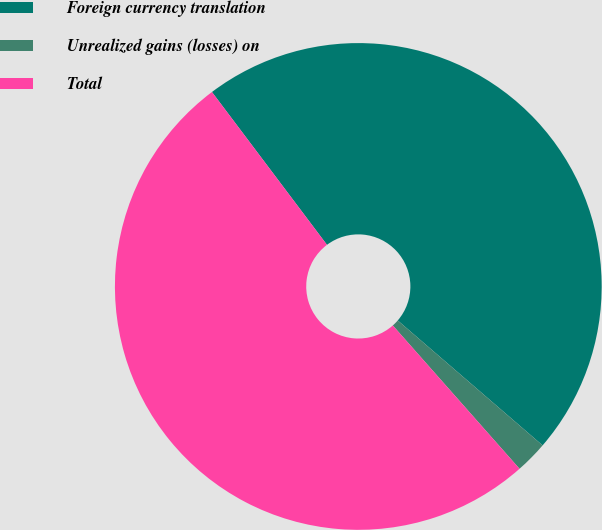Convert chart. <chart><loc_0><loc_0><loc_500><loc_500><pie_chart><fcel>Foreign currency translation<fcel>Unrealized gains (losses) on<fcel>Total<nl><fcel>46.59%<fcel>2.15%<fcel>51.25%<nl></chart> 